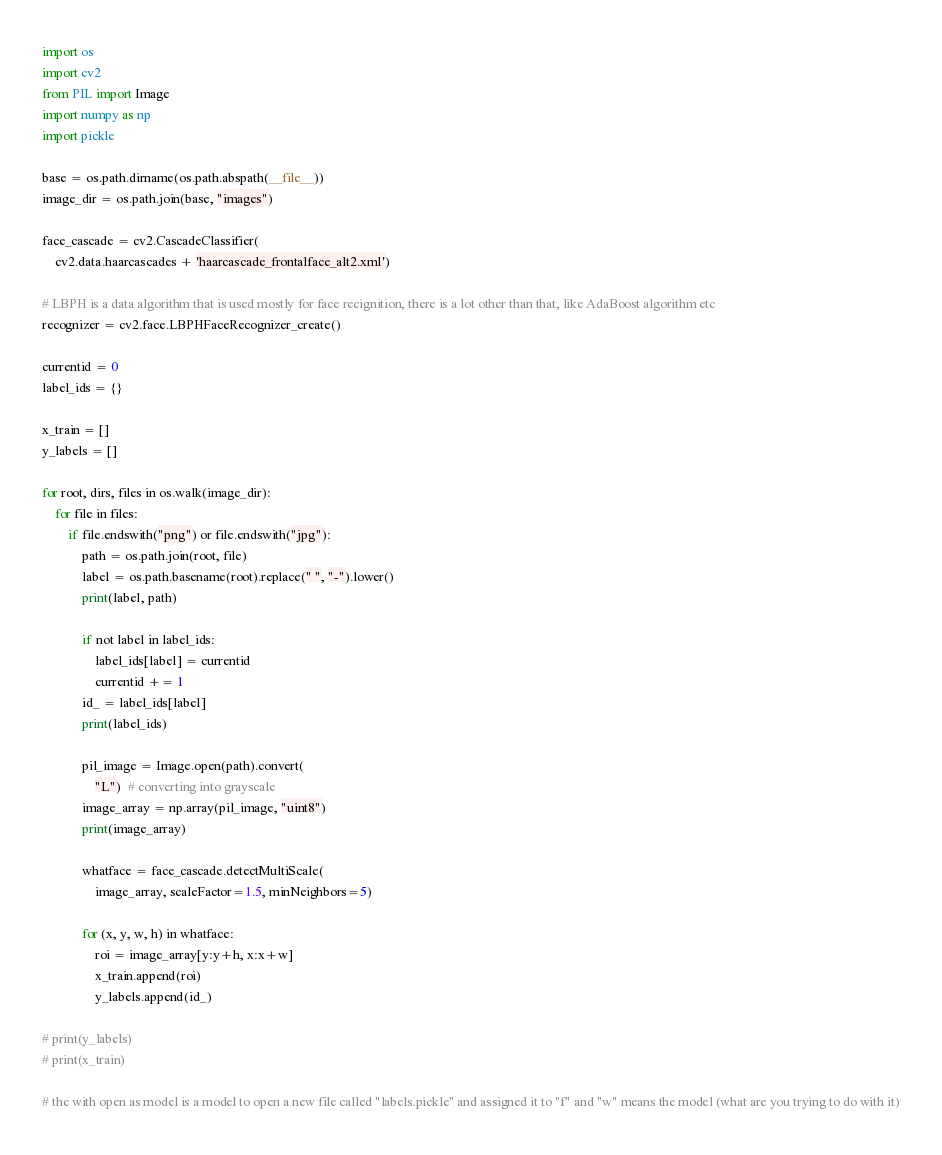<code> <loc_0><loc_0><loc_500><loc_500><_Python_>import os
import cv2
from PIL import Image
import numpy as np
import pickle

base = os.path.dirname(os.path.abspath(__file__))
image_dir = os.path.join(base, "images")

face_cascade = cv2.CascadeClassifier(
    cv2.data.haarcascades + 'haarcascade_frontalface_alt2.xml')

# LBPH is a data algorithm that is used mostly for face recignition, there is a lot other than that, like AdaBoost algorithm etc
recognizer = cv2.face.LBPHFaceRecognizer_create()

currentid = 0
label_ids = {}

x_train = []
y_labels = []

for root, dirs, files in os.walk(image_dir):
    for file in files:
        if file.endswith("png") or file.endswith("jpg"):
            path = os.path.join(root, file)
            label = os.path.basename(root).replace(" ", "-").lower()
            print(label, path)

            if not label in label_ids:
                label_ids[label] = currentid
                currentid += 1
            id_ = label_ids[label]
            print(label_ids)

            pil_image = Image.open(path).convert(
                "L")  # converting into grayscale
            image_array = np.array(pil_image, "uint8")
            print(image_array)

            whatface = face_cascade.detectMultiScale(
                image_array, scaleFactor=1.5, minNeighbors=5)

            for (x, y, w, h) in whatface:
                roi = image_array[y:y+h, x:x+w]
                x_train.append(roi)
                y_labels.append(id_)

# print(y_labels)
# print(x_train)

# the with open as model is a model to open a new file called "labels.pickle" and assigned it to "f" and "w" means the model (what are you trying to do with it)</code> 